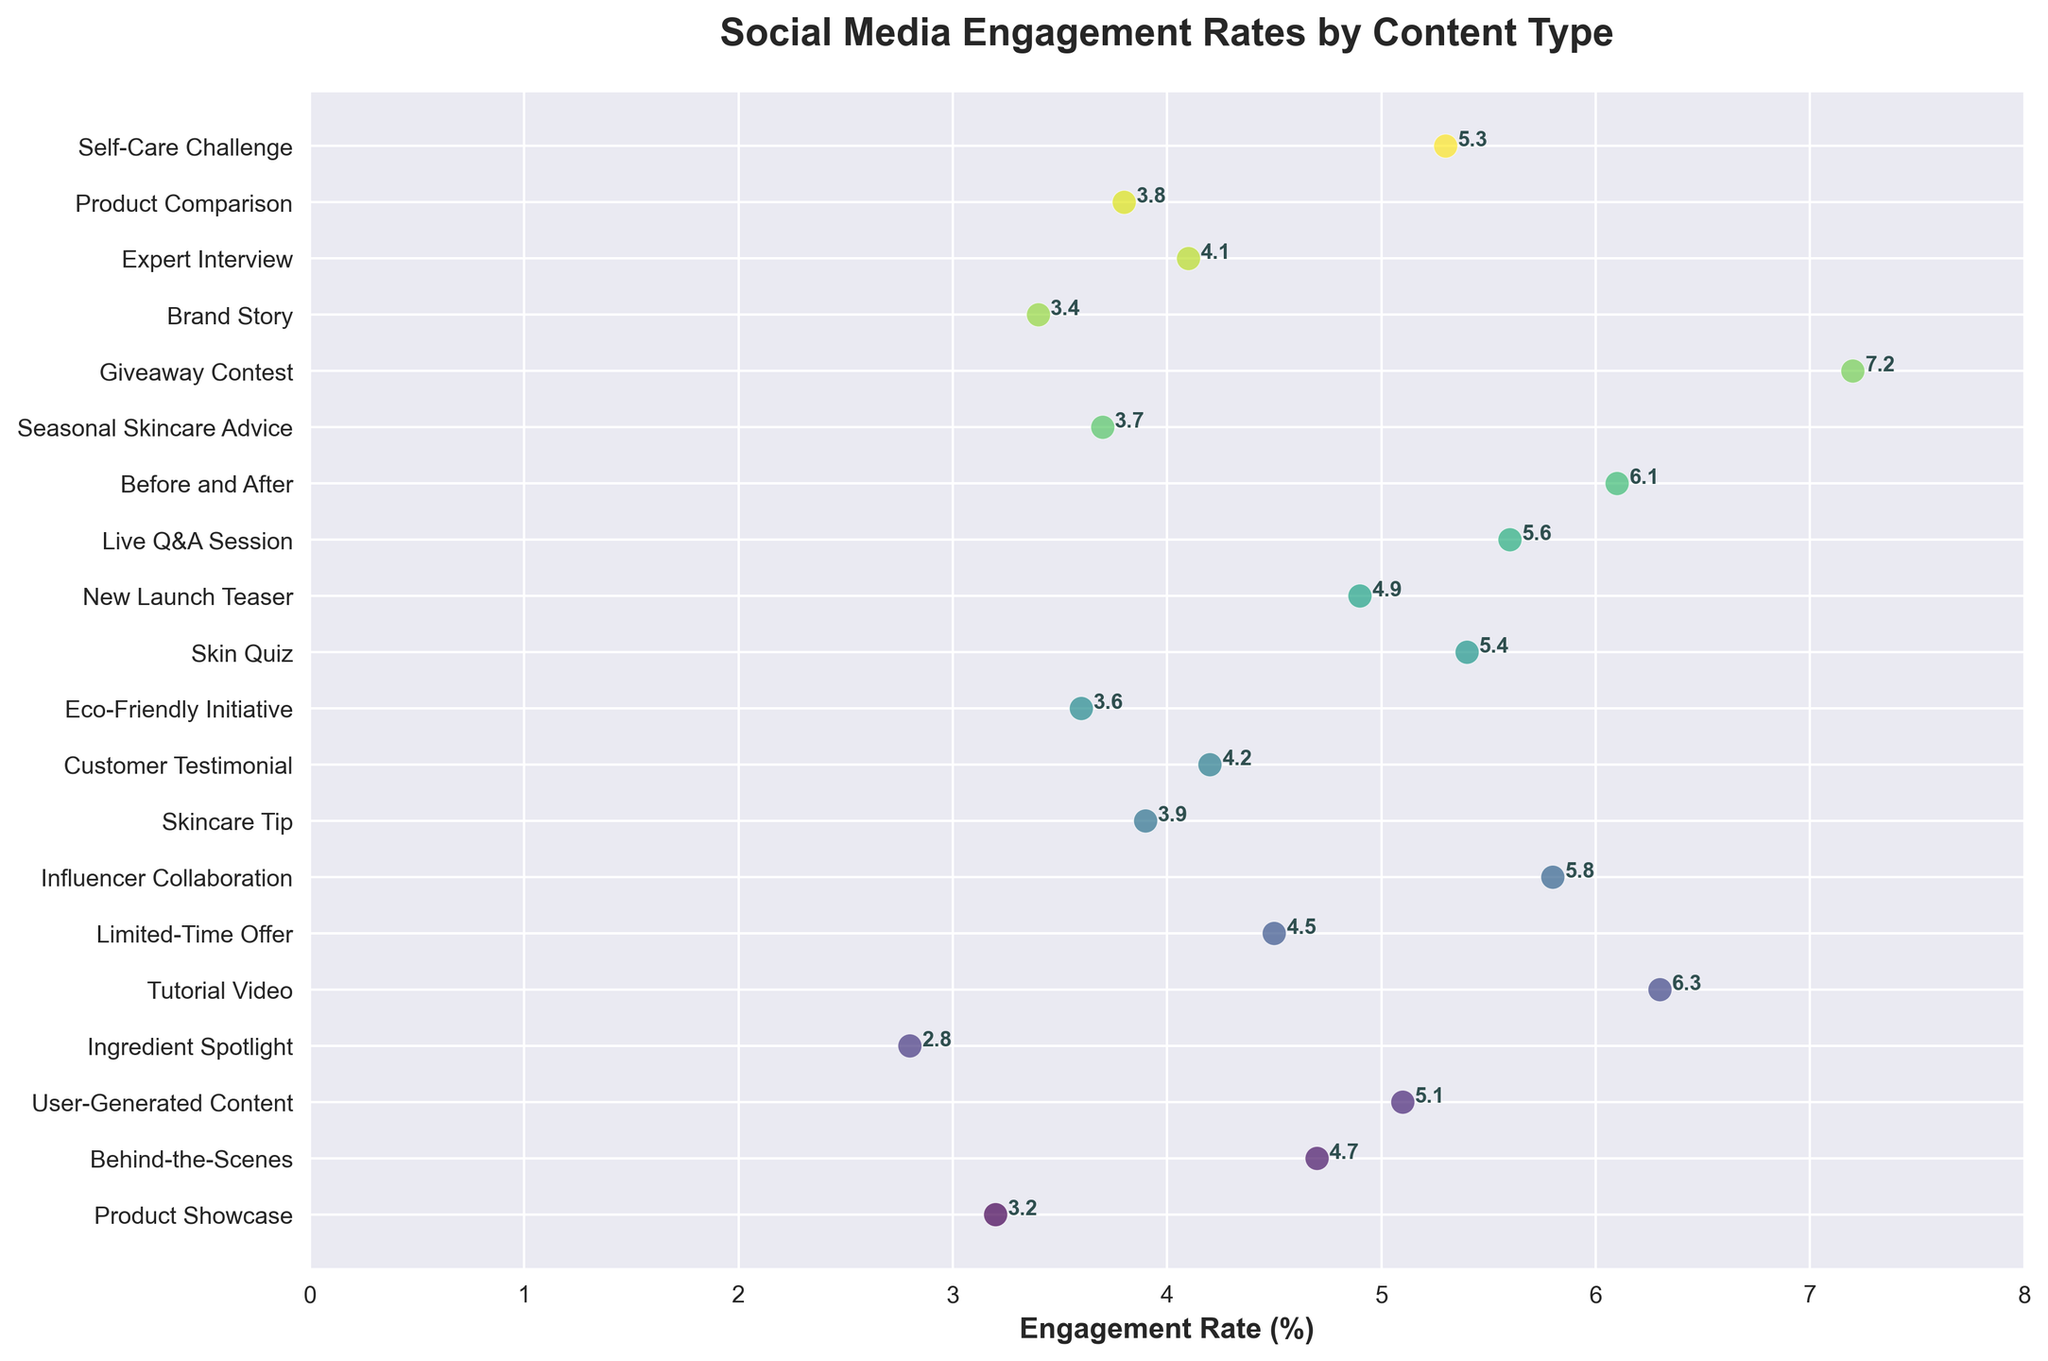What is the engagement rate for the 'Giveaway Contest' content type? Look for the 'Giveaway Contest' label on the y-axis and note its corresponding point's x-axis value, which represents the engagement rate.
Answer: 7.2 What content type has the highest engagement rate? Identify the data point that is the furthest to the right on the x-axis, and note its corresponding label on the y-axis.
Answer: Giveaway Contest Which content type has the lowest engagement rate? Identify the data point that is the furthest to the left on the x-axis, and note its corresponding label on the y-axis.
Answer: Ingredient Spotlight What is the median engagement rate of all content types? List all engagement rates, sort them, and find the middle value. The sorted rates are: 2.8, 3.2, 3.4, 3.6, 3.7, 3.8, 3.9, 4.1, 4.2, 4.5, 4.7, 4.9, 5.1, 5.3, 5.4, 5.6, 5.8, 6.1, 6.3, 7.2. The median value is (4.5 + 4.7)/2 = 4.6.
Answer: 4.6 Which two content types have engagement rates closest to each other? Compare engagement rates of consecutive points in the sorted list to find the smallest difference; the closest are 'Live Q&A Session' (5.6) and 'Influencer Collaboration' (5.8) with a difference of only 0.2.
Answer: Live Q&A Session and Influencer Collaboration Is the engagement rate for 'Tutorial Video' above or below the median engagement rate? Compare the 'Tutorial Video' rate (6.3) with the median rate (4.6); 6.3 > 4.6 means it is above.
Answer: Above How many content types have an engagement rate above 5%? Count the number of points with x-axis values greater than 5. They are: User-Generated Content (5.1), Tutorial Video (6.3), Influencer Collaboration (5.8), Skin Quiz (5.4), Live Q&A Session (5.6), Before and After (6.1), Giveaway Contest (7.2), and Self-Care Challenge (5.3). Total = 8.
Answer: 8 Which content type has the highest engagement rate among 'User-Generated Content', 'Customer Testimonial', and 'Brand Story'? Compare the engagement rates for these types: 'User-Generated Content' (5.1), 'Customer Testimonial' (4.2), 'Brand Story' (3.4). Highest is 'User-Generated Content.'
Answer: User-Generated Content 